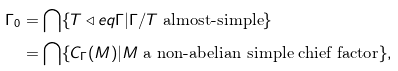Convert formula to latex. <formula><loc_0><loc_0><loc_500><loc_500>\Gamma _ { 0 } & = \bigcap \{ T \triangleleft e q \Gamma | \Gamma / T \text { almost-simple} \} \\ & = \bigcap \{ C _ { \Gamma } ( M ) | M \text { a non-abelian simple   chief factor} \} ,</formula> 